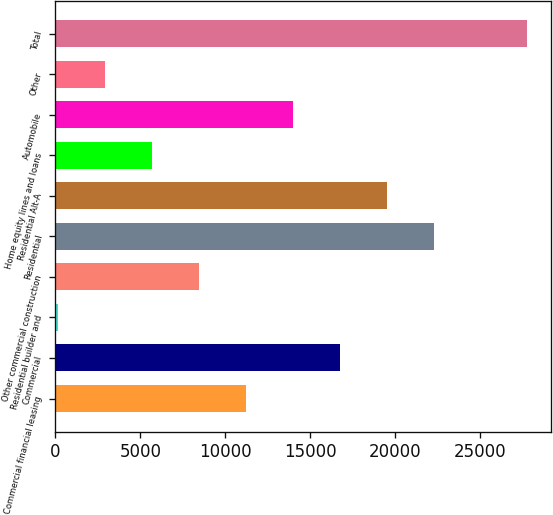<chart> <loc_0><loc_0><loc_500><loc_500><bar_chart><fcel>Commercial financial leasing<fcel>Commercial<fcel>Residential builder and<fcel>Other commercial construction<fcel>Residential<fcel>Residential Alt-A<fcel>Home equity lines and loans<fcel>Automobile<fcel>Other<fcel>Total<nl><fcel>11204.8<fcel>16736.2<fcel>142<fcel>8439.1<fcel>22267.6<fcel>19501.9<fcel>5673.4<fcel>13970.5<fcel>2907.7<fcel>27799<nl></chart> 